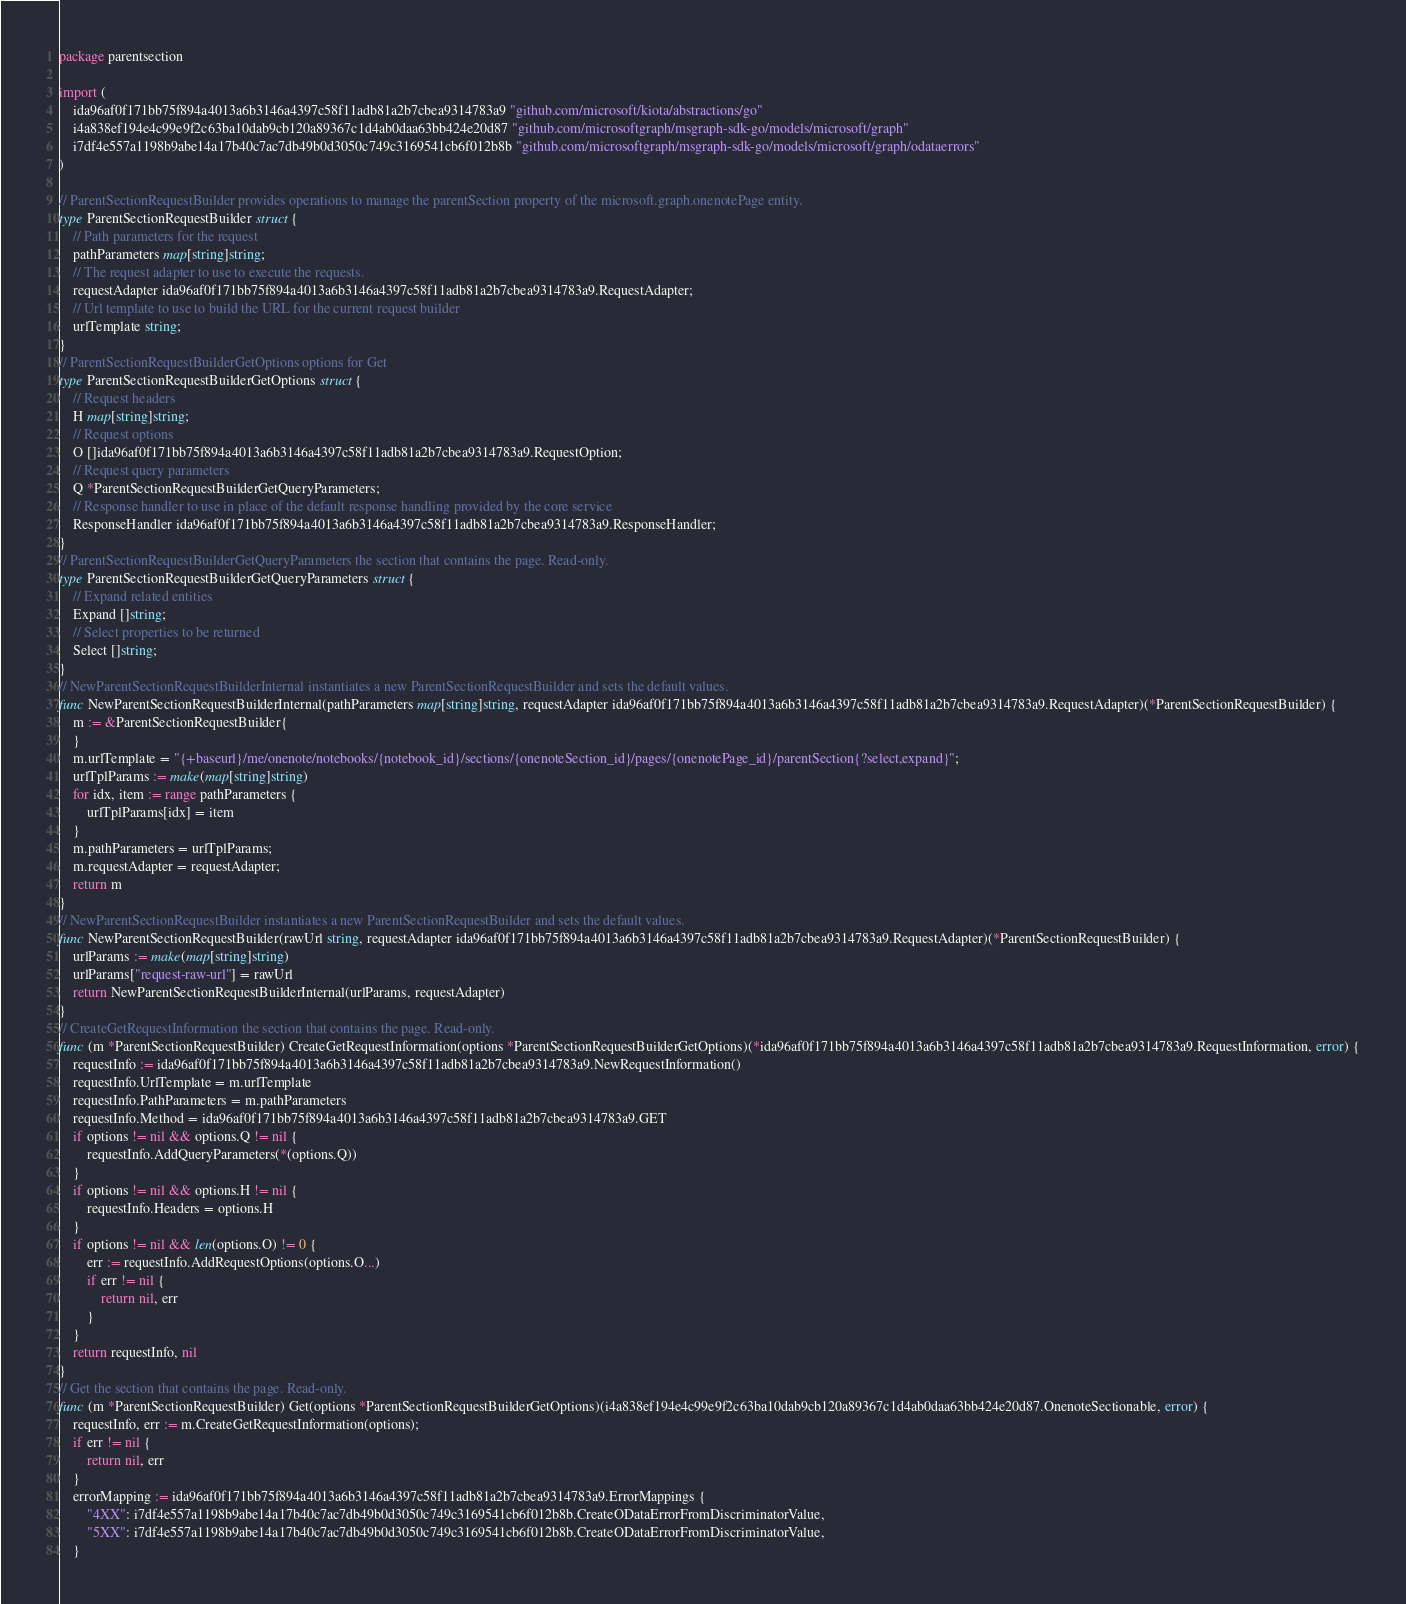<code> <loc_0><loc_0><loc_500><loc_500><_Go_>package parentsection

import (
    ida96af0f171bb75f894a4013a6b3146a4397c58f11adb81a2b7cbea9314783a9 "github.com/microsoft/kiota/abstractions/go"
    i4a838ef194e4c99e9f2c63ba10dab9cb120a89367c1d4ab0daa63bb424e20d87 "github.com/microsoftgraph/msgraph-sdk-go/models/microsoft/graph"
    i7df4e557a1198b9abe14a17b40c7ac7db49b0d3050c749c3169541cb6f012b8b "github.com/microsoftgraph/msgraph-sdk-go/models/microsoft/graph/odataerrors"
)

// ParentSectionRequestBuilder provides operations to manage the parentSection property of the microsoft.graph.onenotePage entity.
type ParentSectionRequestBuilder struct {
    // Path parameters for the request
    pathParameters map[string]string;
    // The request adapter to use to execute the requests.
    requestAdapter ida96af0f171bb75f894a4013a6b3146a4397c58f11adb81a2b7cbea9314783a9.RequestAdapter;
    // Url template to use to build the URL for the current request builder
    urlTemplate string;
}
// ParentSectionRequestBuilderGetOptions options for Get
type ParentSectionRequestBuilderGetOptions struct {
    // Request headers
    H map[string]string;
    // Request options
    O []ida96af0f171bb75f894a4013a6b3146a4397c58f11adb81a2b7cbea9314783a9.RequestOption;
    // Request query parameters
    Q *ParentSectionRequestBuilderGetQueryParameters;
    // Response handler to use in place of the default response handling provided by the core service
    ResponseHandler ida96af0f171bb75f894a4013a6b3146a4397c58f11adb81a2b7cbea9314783a9.ResponseHandler;
}
// ParentSectionRequestBuilderGetQueryParameters the section that contains the page. Read-only.
type ParentSectionRequestBuilderGetQueryParameters struct {
    // Expand related entities
    Expand []string;
    // Select properties to be returned
    Select []string;
}
// NewParentSectionRequestBuilderInternal instantiates a new ParentSectionRequestBuilder and sets the default values.
func NewParentSectionRequestBuilderInternal(pathParameters map[string]string, requestAdapter ida96af0f171bb75f894a4013a6b3146a4397c58f11adb81a2b7cbea9314783a9.RequestAdapter)(*ParentSectionRequestBuilder) {
    m := &ParentSectionRequestBuilder{
    }
    m.urlTemplate = "{+baseurl}/me/onenote/notebooks/{notebook_id}/sections/{onenoteSection_id}/pages/{onenotePage_id}/parentSection{?select,expand}";
    urlTplParams := make(map[string]string)
    for idx, item := range pathParameters {
        urlTplParams[idx] = item
    }
    m.pathParameters = urlTplParams;
    m.requestAdapter = requestAdapter;
    return m
}
// NewParentSectionRequestBuilder instantiates a new ParentSectionRequestBuilder and sets the default values.
func NewParentSectionRequestBuilder(rawUrl string, requestAdapter ida96af0f171bb75f894a4013a6b3146a4397c58f11adb81a2b7cbea9314783a9.RequestAdapter)(*ParentSectionRequestBuilder) {
    urlParams := make(map[string]string)
    urlParams["request-raw-url"] = rawUrl
    return NewParentSectionRequestBuilderInternal(urlParams, requestAdapter)
}
// CreateGetRequestInformation the section that contains the page. Read-only.
func (m *ParentSectionRequestBuilder) CreateGetRequestInformation(options *ParentSectionRequestBuilderGetOptions)(*ida96af0f171bb75f894a4013a6b3146a4397c58f11adb81a2b7cbea9314783a9.RequestInformation, error) {
    requestInfo := ida96af0f171bb75f894a4013a6b3146a4397c58f11adb81a2b7cbea9314783a9.NewRequestInformation()
    requestInfo.UrlTemplate = m.urlTemplate
    requestInfo.PathParameters = m.pathParameters
    requestInfo.Method = ida96af0f171bb75f894a4013a6b3146a4397c58f11adb81a2b7cbea9314783a9.GET
    if options != nil && options.Q != nil {
        requestInfo.AddQueryParameters(*(options.Q))
    }
    if options != nil && options.H != nil {
        requestInfo.Headers = options.H
    }
    if options != nil && len(options.O) != 0 {
        err := requestInfo.AddRequestOptions(options.O...)
        if err != nil {
            return nil, err
        }
    }
    return requestInfo, nil
}
// Get the section that contains the page. Read-only.
func (m *ParentSectionRequestBuilder) Get(options *ParentSectionRequestBuilderGetOptions)(i4a838ef194e4c99e9f2c63ba10dab9cb120a89367c1d4ab0daa63bb424e20d87.OnenoteSectionable, error) {
    requestInfo, err := m.CreateGetRequestInformation(options);
    if err != nil {
        return nil, err
    }
    errorMapping := ida96af0f171bb75f894a4013a6b3146a4397c58f11adb81a2b7cbea9314783a9.ErrorMappings {
        "4XX": i7df4e557a1198b9abe14a17b40c7ac7db49b0d3050c749c3169541cb6f012b8b.CreateODataErrorFromDiscriminatorValue,
        "5XX": i7df4e557a1198b9abe14a17b40c7ac7db49b0d3050c749c3169541cb6f012b8b.CreateODataErrorFromDiscriminatorValue,
    }</code> 